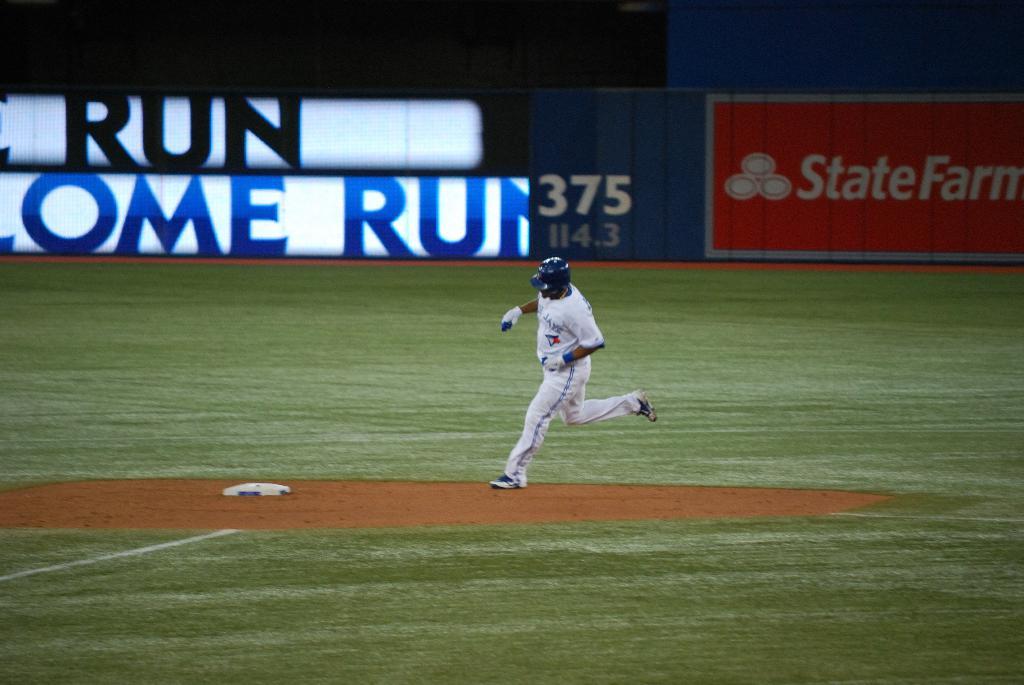What company is advertising in the background?
Provide a succinct answer. State farm. 